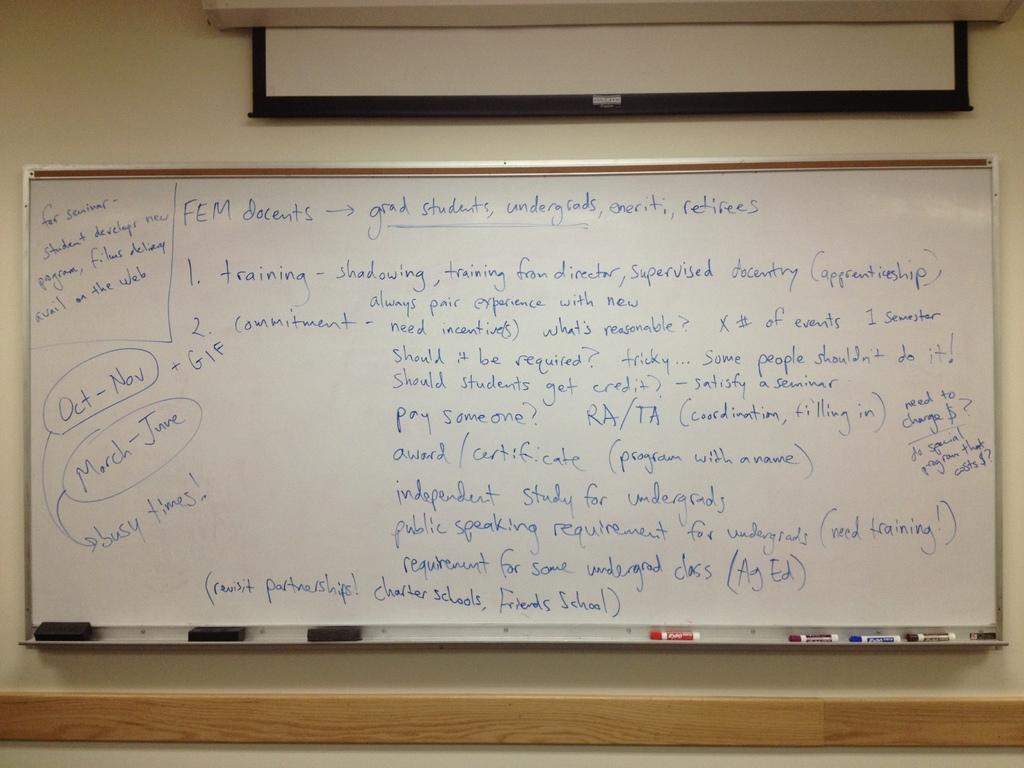<image>
Summarize the visual content of the image. October, November, and March through June will be busy times. 